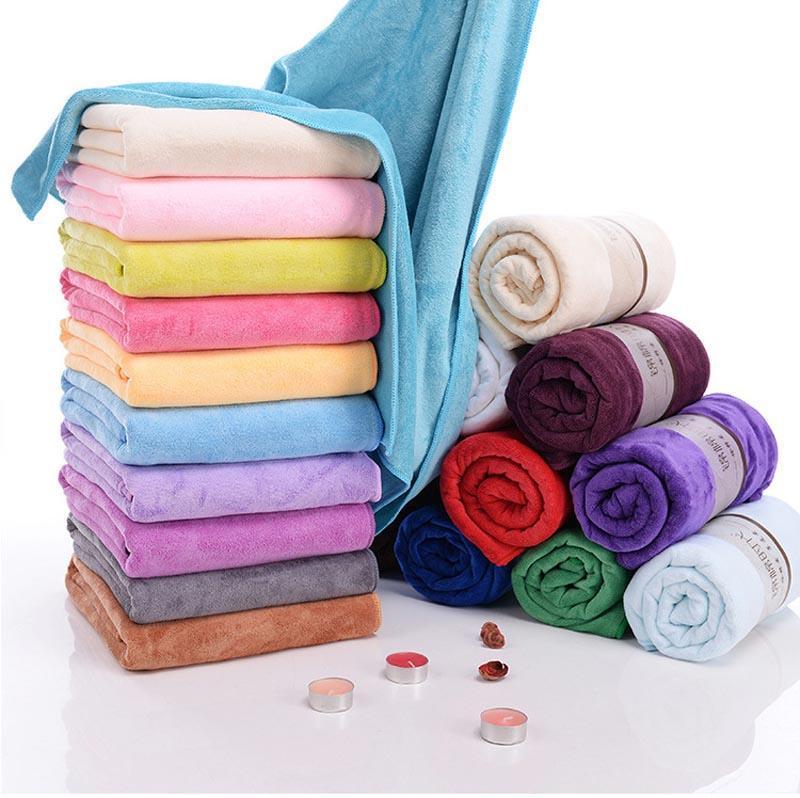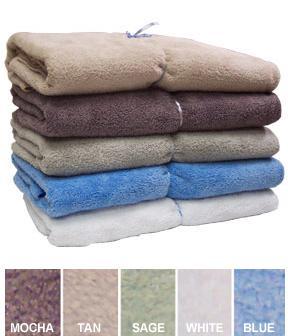The first image is the image on the left, the second image is the image on the right. Assess this claim about the two images: "One image features exactly five folded towels in primarily blue and brown shades.". Correct or not? Answer yes or no. Yes. 